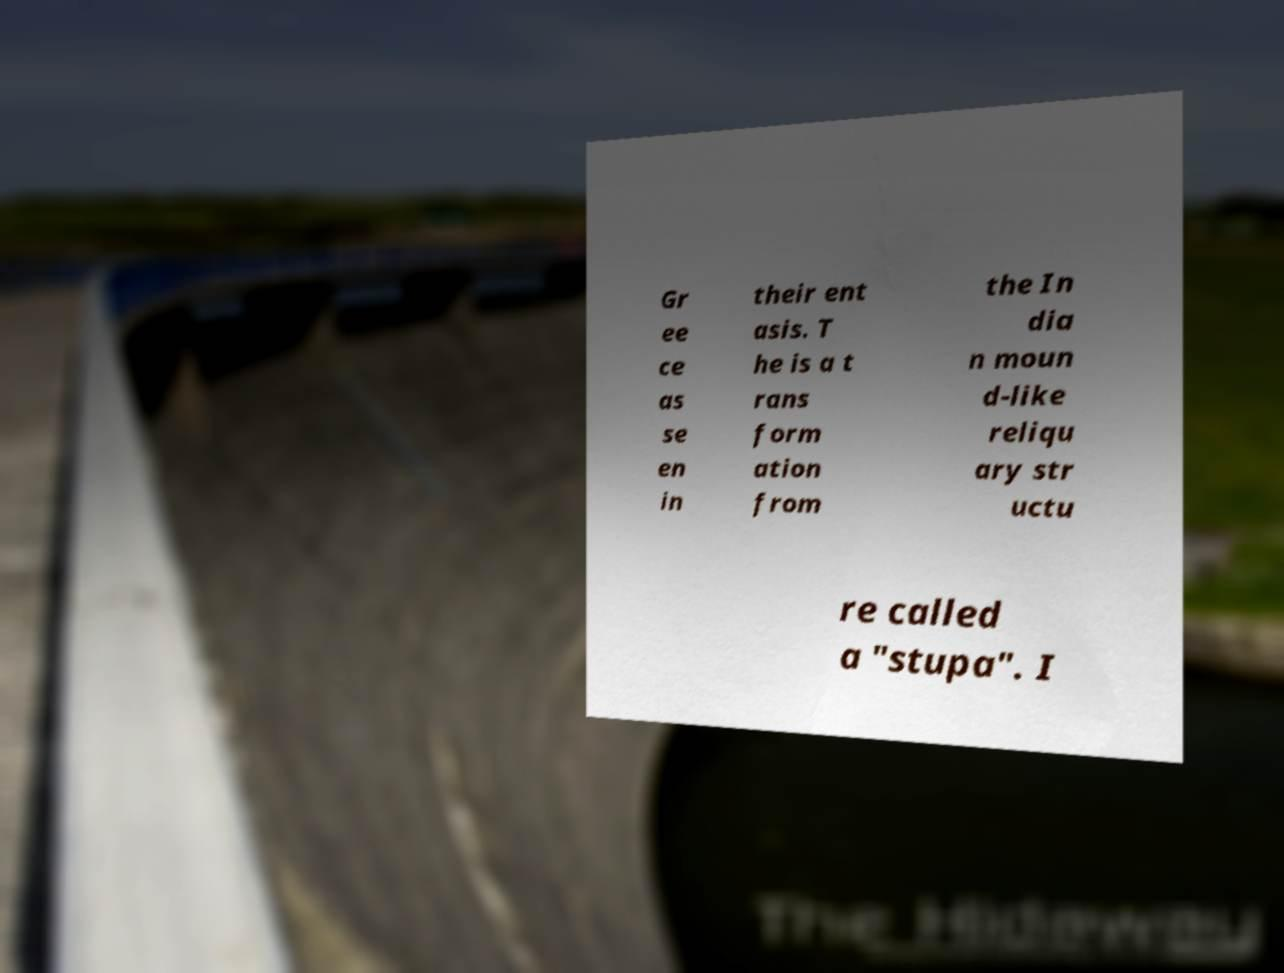For documentation purposes, I need the text within this image transcribed. Could you provide that? Gr ee ce as se en in their ent asis. T he is a t rans form ation from the In dia n moun d-like reliqu ary str uctu re called a "stupa". I 